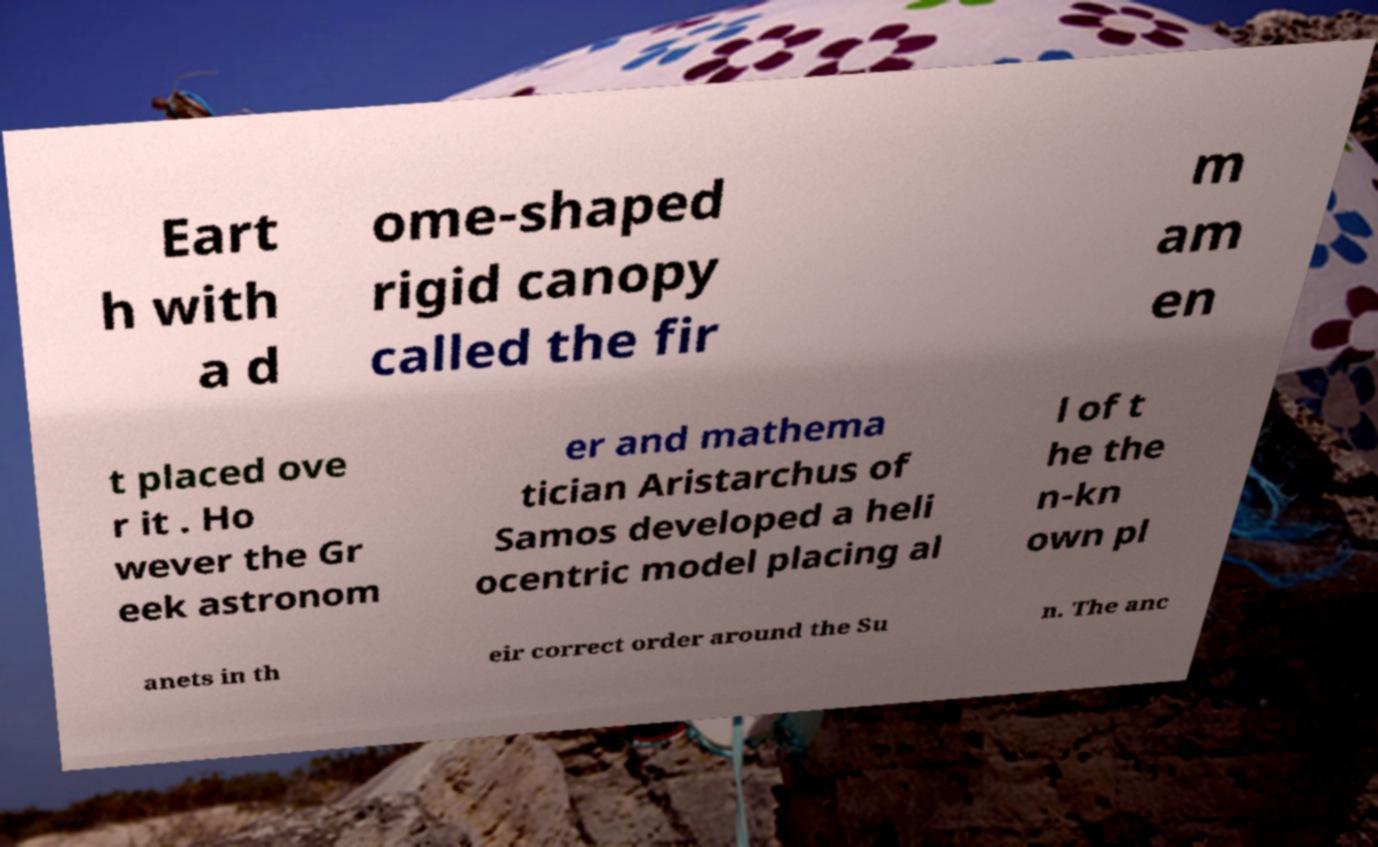Could you extract and type out the text from this image? Eart h with a d ome-shaped rigid canopy called the fir m am en t placed ove r it . Ho wever the Gr eek astronom er and mathema tician Aristarchus of Samos developed a heli ocentric model placing al l of t he the n-kn own pl anets in th eir correct order around the Su n. The anc 